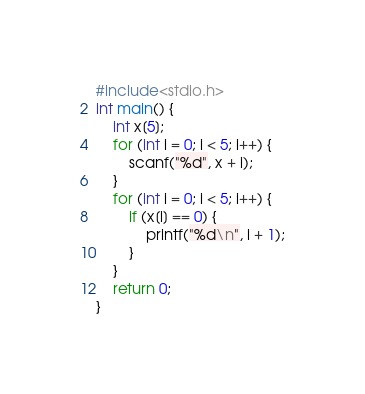Convert code to text. <code><loc_0><loc_0><loc_500><loc_500><_C_>#include<stdio.h>
int main() {
	int x[5];
	for (int i = 0; i < 5; i++) {
		scanf("%d", x + i);
	}
	for (int i = 0; i < 5; i++) {
		if (x[i] == 0) {
			printf("%d\n", i + 1);
		}
	}
	return 0;
}</code> 